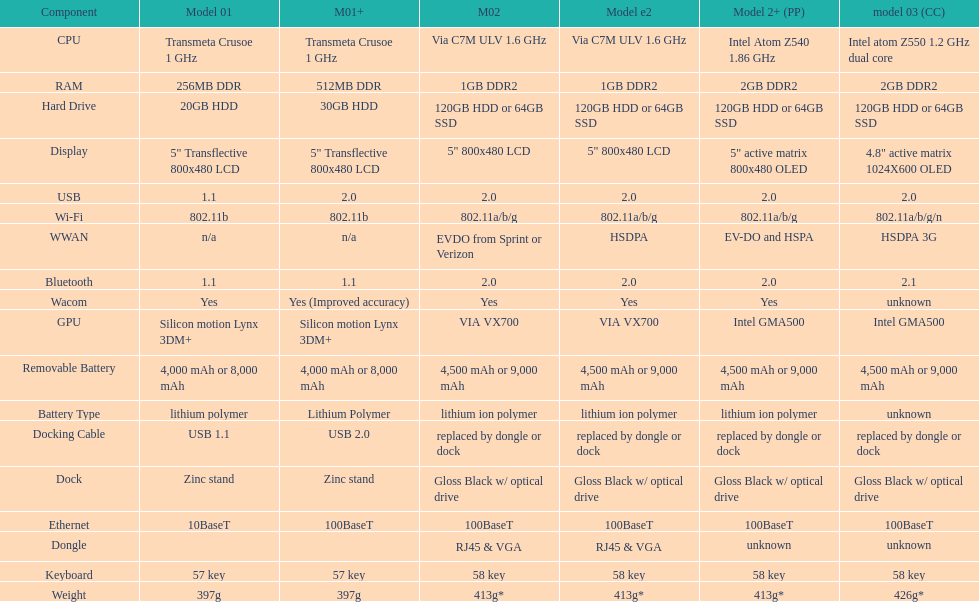What is the average number of models that have usb 2.0? 5. 